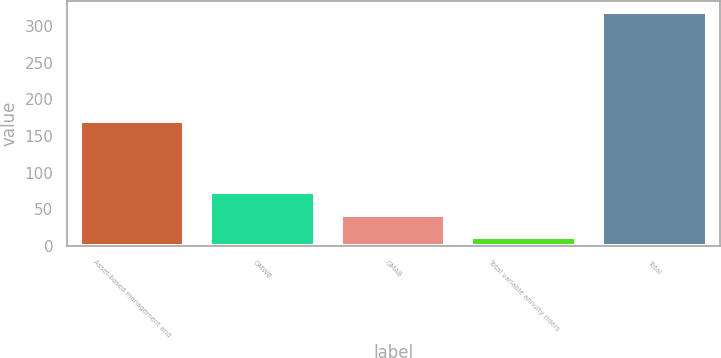<chart> <loc_0><loc_0><loc_500><loc_500><bar_chart><fcel>Asset-based management and<fcel>GMWB<fcel>GMAB<fcel>Total variable annuity riders<fcel>Total<nl><fcel>170<fcel>73.4<fcel>42.7<fcel>12<fcel>319<nl></chart> 